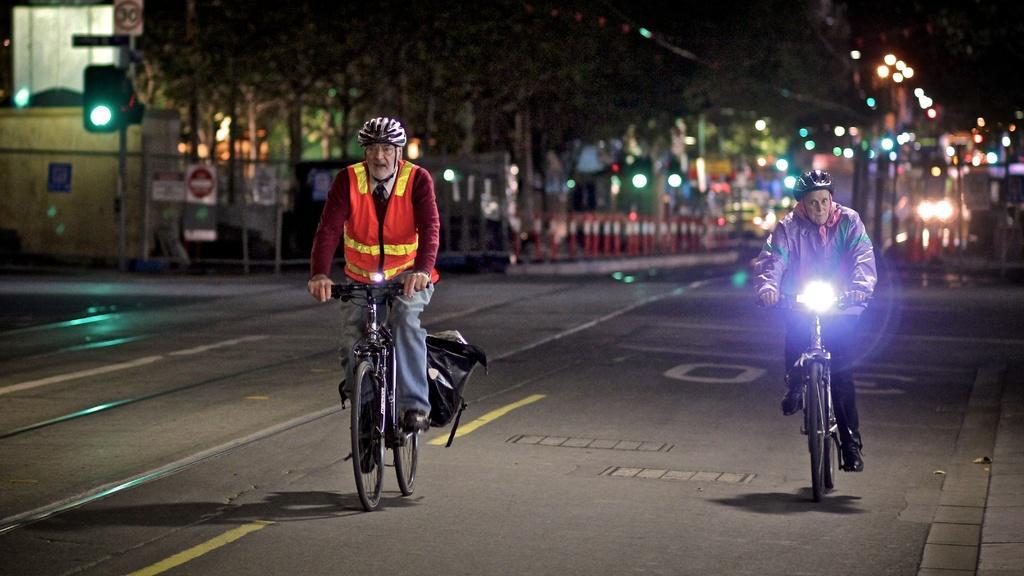How would you summarize this image in a sentence or two? There are two members on The Road Riding a bicycle. Both of them were wearing helmets. In the background there is a signal light and some trees here. 